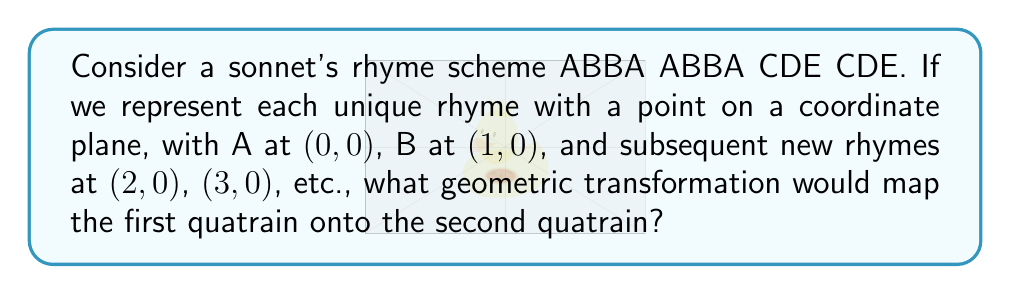Give your solution to this math problem. Let's approach this step-by-step:

1) First, we need to plot the points for the rhyme scheme:
   A: (0,0), B: (1,0), B: (1,1), A: (0,1)

2) This forms a square with side length 1 unit.

3) The second quatrain has the same rhyme scheme (ABBA), so it will form an identical square.

4) To map the first quatrain onto the second, we need to move the square without changing its shape or orientation.

5) This movement is a translation. Specifically, we need to move the square 2 units to the right.

6) In geometric terms, this translation can be represented as:

   $$(x,y) \rightarrow (x+2,y)$$

7) This transformation will move A from (0,0) to (2,0), B from (1,0) to (3,0), B from (1,1) to (3,1), and A from (0,1) to (2,1).

8) This perfectly maps the first quatrain onto the second, preserving the rhyme scheme.
Answer: Translation by vector $\langle 2,0 \rangle$ 